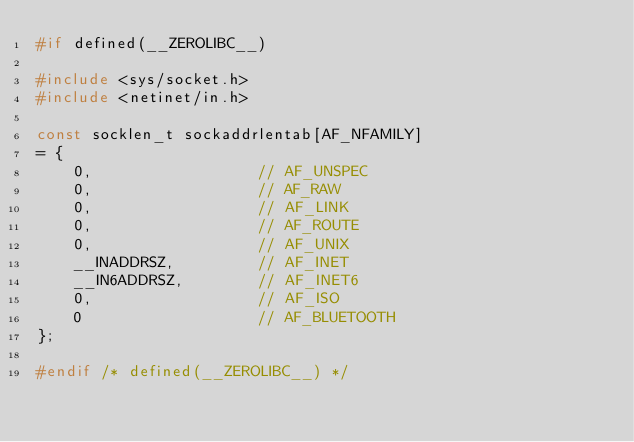<code> <loc_0><loc_0><loc_500><loc_500><_C_>#if defined(__ZEROLIBC__)

#include <sys/socket.h>
#include <netinet/in.h>

const socklen_t sockaddrlentab[AF_NFAMILY]
= {
    0,                  // AF_UNSPEC
    0,                  // AF_RAW
    0,                  // AF_LINK
    0,                  // AF_ROUTE
    0,                  // AF_UNIX
    __INADDRSZ,         // AF_INET
    __IN6ADDRSZ,        // AF_INET6
    0,                  // AF_ISO
    0                   // AF_BLUETOOTH
};

#endif /* defined(__ZEROLIBC__) */

</code> 